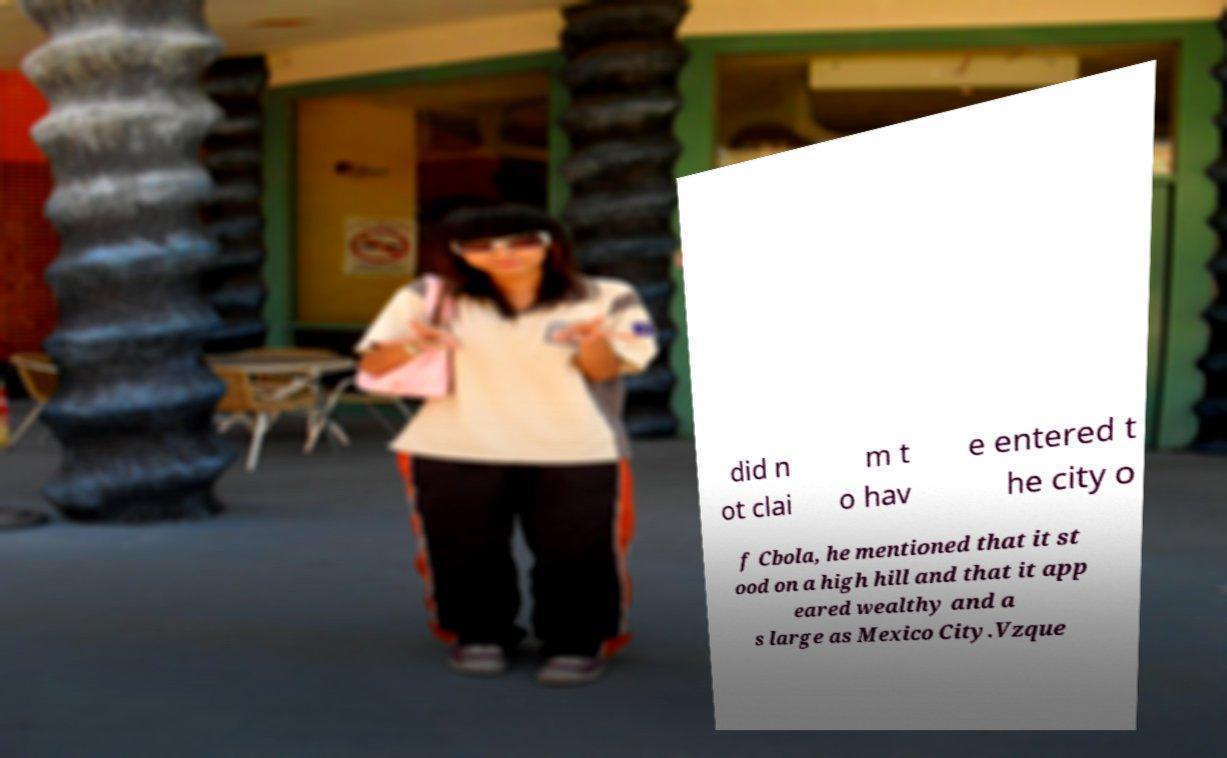Could you assist in decoding the text presented in this image and type it out clearly? did n ot clai m t o hav e entered t he city o f Cbola, he mentioned that it st ood on a high hill and that it app eared wealthy and a s large as Mexico City.Vzque 